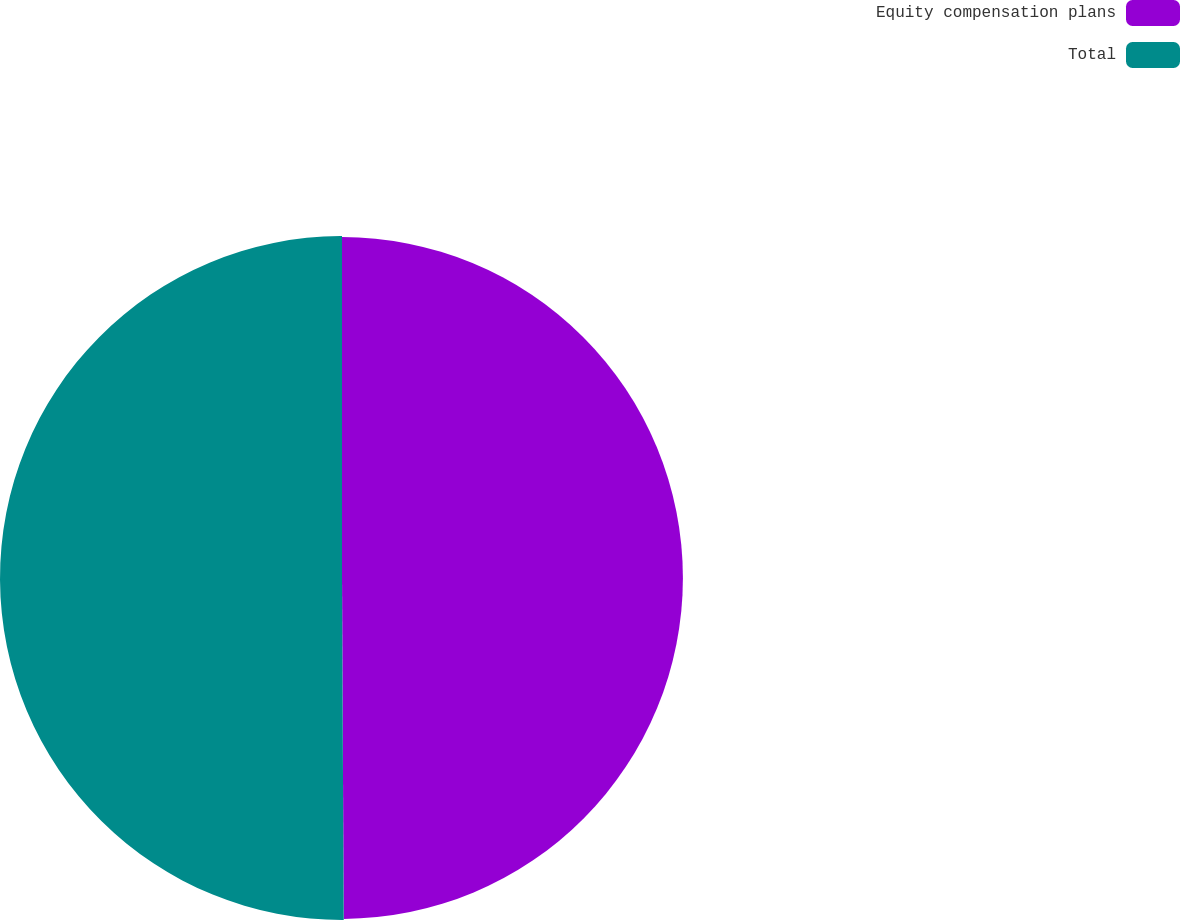<chart> <loc_0><loc_0><loc_500><loc_500><pie_chart><fcel>Equity compensation plans<fcel>Total<nl><fcel>49.92%<fcel>50.08%<nl></chart> 